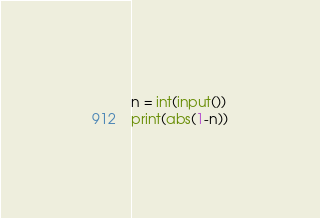<code> <loc_0><loc_0><loc_500><loc_500><_Python_>n = int(input())
print(abs(1-n))</code> 